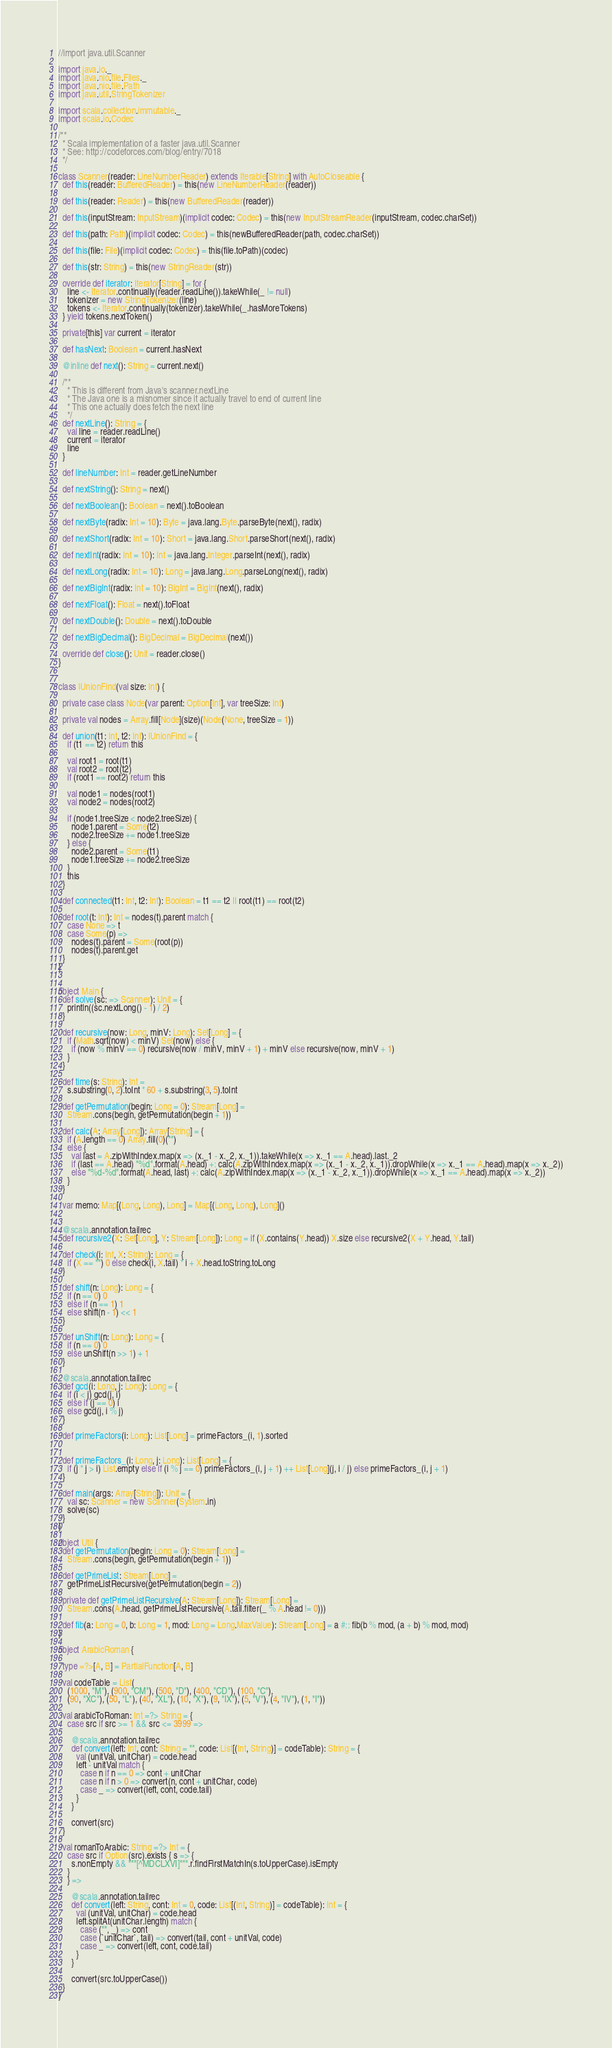<code> <loc_0><loc_0><loc_500><loc_500><_Scala_>//import java.util.Scanner

import java.io._
import java.nio.file.Files._
import java.nio.file.Path
import java.util.StringTokenizer

import scala.collection.immutable._
import scala.io.Codec

/**
  * Scala implementation of a faster java.util.Scanner
  * See: http://codeforces.com/blog/entry/7018
  */

class Scanner(reader: LineNumberReader) extends Iterable[String] with AutoCloseable {
  def this(reader: BufferedReader) = this(new LineNumberReader(reader))

  def this(reader: Reader) = this(new BufferedReader(reader))

  def this(inputStream: InputStream)(implicit codec: Codec) = this(new InputStreamReader(inputStream, codec.charSet))

  def this(path: Path)(implicit codec: Codec) = this(newBufferedReader(path, codec.charSet))

  def this(file: File)(implicit codec: Codec) = this(file.toPath)(codec)

  def this(str: String) = this(new StringReader(str))

  override def iterator: Iterator[String] = for {
    line <- Iterator.continually(reader.readLine()).takeWhile(_ != null)
    tokenizer = new StringTokenizer(line)
    tokens <- Iterator.continually(tokenizer).takeWhile(_.hasMoreTokens)
  } yield tokens.nextToken()

  private[this] var current = iterator

  def hasNext: Boolean = current.hasNext

  @inline def next(): String = current.next()

  /**
    * This is different from Java's scanner.nextLine
    * The Java one is a misnomer since it actually travel to end of current line
    * This one actually does fetch the next line
    */
  def nextLine(): String = {
    val line = reader.readLine()
    current = iterator
    line
  }

  def lineNumber: Int = reader.getLineNumber

  def nextString(): String = next()

  def nextBoolean(): Boolean = next().toBoolean

  def nextByte(radix: Int = 10): Byte = java.lang.Byte.parseByte(next(), radix)

  def nextShort(radix: Int = 10): Short = java.lang.Short.parseShort(next(), radix)

  def nextInt(radix: Int = 10): Int = java.lang.Integer.parseInt(next(), radix)

  def nextLong(radix: Int = 10): Long = java.lang.Long.parseLong(next(), radix)

  def nextBigInt(radix: Int = 10): BigInt = BigInt(next(), radix)

  def nextFloat(): Float = next().toFloat

  def nextDouble(): Double = next().toDouble

  def nextBigDecimal(): BigDecimal = BigDecimal(next())

  override def close(): Unit = reader.close()
}


class IUnionFind(val size: Int) {

  private case class Node(var parent: Option[Int], var treeSize: Int)

  private val nodes = Array.fill[Node](size)(Node(None, treeSize = 1))

  def union(t1: Int, t2: Int): IUnionFind = {
    if (t1 == t2) return this

    val root1 = root(t1)
    val root2 = root(t2)
    if (root1 == root2) return this

    val node1 = nodes(root1)
    val node2 = nodes(root2)

    if (node1.treeSize < node2.treeSize) {
      node1.parent = Some(t2)
      node2.treeSize += node1.treeSize
    } else {
      node2.parent = Some(t1)
      node1.treeSize += node2.treeSize
    }
    this
  }

  def connected(t1: Int, t2: Int): Boolean = t1 == t2 || root(t1) == root(t2)

  def root(t: Int): Int = nodes(t).parent match {
    case None => t
    case Some(p) =>
      nodes(t).parent = Some(root(p))
      nodes(t).parent.get
  }
}


object Main {
  def solve(sc: => Scanner): Unit = {
    println((sc.nextLong() - 1) / 2)
  }

  def recursive(now: Long, minV: Long): Set[Long] = {
    if (Math.sqrt(now) < minV) Set(now) else {
      if (now % minV == 0) recursive(now / minV, minV + 1) + minV else recursive(now, minV + 1)
    }
  }

  def time(s: String): Int =
    s.substring(0, 2).toInt * 60 + s.substring(3, 5).toInt

  def getPermutation(begin: Long = 0): Stream[Long] =
    Stream.cons(begin, getPermutation(begin + 1))

  def calc(A: Array[Long]): Array[String] = {
    if (A.length == 0) Array.fill(0)("")
    else {
      val last = A.zipWithIndex.map(x => (x._1 - x._2, x._1)).takeWhile(x => x._1 == A.head).last._2
      if (last == A.head) "%d".format(A.head) +: calc(A.zipWithIndex.map(x => (x._1 - x._2, x._1)).dropWhile(x => x._1 == A.head).map(x => x._2))
      else "%d-%d".format(A.head, last) +: calc(A.zipWithIndex.map(x => (x._1 - x._2, x._1)).dropWhile(x => x._1 == A.head).map(x => x._2))
    }
  }

  var memo: Map[(Long, Long), Long] = Map[(Long, Long), Long]()


  @scala.annotation.tailrec
  def recursive2(X: Set[Long], Y: Stream[Long]): Long = if (X.contains(Y.head)) X.size else recursive2(X + Y.head, Y.tail)

  def check(i: Int, X: String): Long = {
    if (X == "") 0 else check(i, X.tail) * i + X.head.toString.toLong
  }

  def shift(n: Long): Long = {
    if (n == 0) 0
    else if (n == 1) 1
    else shift(n - 1) << 1
  }

  def unShift(n: Long): Long = {
    if (n == 0) 0
    else unShift(n >> 1) + 1
  }

  @scala.annotation.tailrec
  def gcd(i: Long, j: Long): Long = {
    if (i < j) gcd(j, i)
    else if (j == 0) i
    else gcd(j, i % j)
  }

  def primeFactors(i: Long): List[Long] = primeFactors_(i, 1).sorted


  def primeFactors_(i: Long, j: Long): List[Long] = {
    if (j * j > i) List.empty else if (i % j == 0) primeFactors_(i, j + 1) ++ List[Long](j, i / j) else primeFactors_(i, j + 1)
  }

  def main(args: Array[String]): Unit = {
    val sc: Scanner = new Scanner(System.in)
    solve(sc)
  }
}

object Util {
  def getPermutation(begin: Long = 0): Stream[Long] =
    Stream.cons(begin, getPermutation(begin + 1))

  def getPrimeList: Stream[Long] =
    getPrimeListRecursive(getPermutation(begin = 2))

  private def getPrimeListRecursive(A: Stream[Long]): Stream[Long] =
    Stream.cons(A.head, getPrimeListRecursive(A.tail.filter(_ % A.head != 0)))

  def fib(a: Long = 0, b: Long = 1, mod: Long = Long.MaxValue): Stream[Long] = a #:: fib(b % mod, (a + b) % mod, mod)
}

object ArabicRoman {

  type =?>[A, B] = PartialFunction[A, B]

  val codeTable = List(
    (1000, "M"), (900, "CM"), (500, "D"), (400, "CD"), (100, "C"),
    (90, "XC"), (50, "L"), (40, "XL"), (10, "X"), (9, "IX"), (5, "V"), (4, "IV"), (1, "I"))

  val arabicToRoman: Int =?> String = {
    case src if src >= 1 && src <= 3999 =>

      @scala.annotation.tailrec
      def convert(left: Int, cont: String = "", code: List[(Int, String)] = codeTable): String = {
        val (unitVal, unitChar) = code.head
        left - unitVal match {
          case n if n == 0 => cont + unitChar
          case n if n > 0 => convert(n, cont + unitChar, code)
          case _ => convert(left, cont, code.tail)
        }
      }

      convert(src)
  }

  val romanToArabic: String =?> Int = {
    case src if Option(src).exists { s => {
      s.nonEmpty && """[^MDCLXVI]""".r.findFirstMatchIn(s.toUpperCase).isEmpty
    }
    } =>

      @scala.annotation.tailrec
      def convert(left: String, cont: Int = 0, code: List[(Int, String)] = codeTable): Int = {
        val (unitVal, unitChar) = code.head
        left.splitAt(unitChar.length) match {
          case ("", _) => cont
          case (`unitChar`, tail) => convert(tail, cont + unitVal, code)
          case _ => convert(left, cont, code.tail)
        }
      }

      convert(src.toUpperCase())
  }
}
</code> 